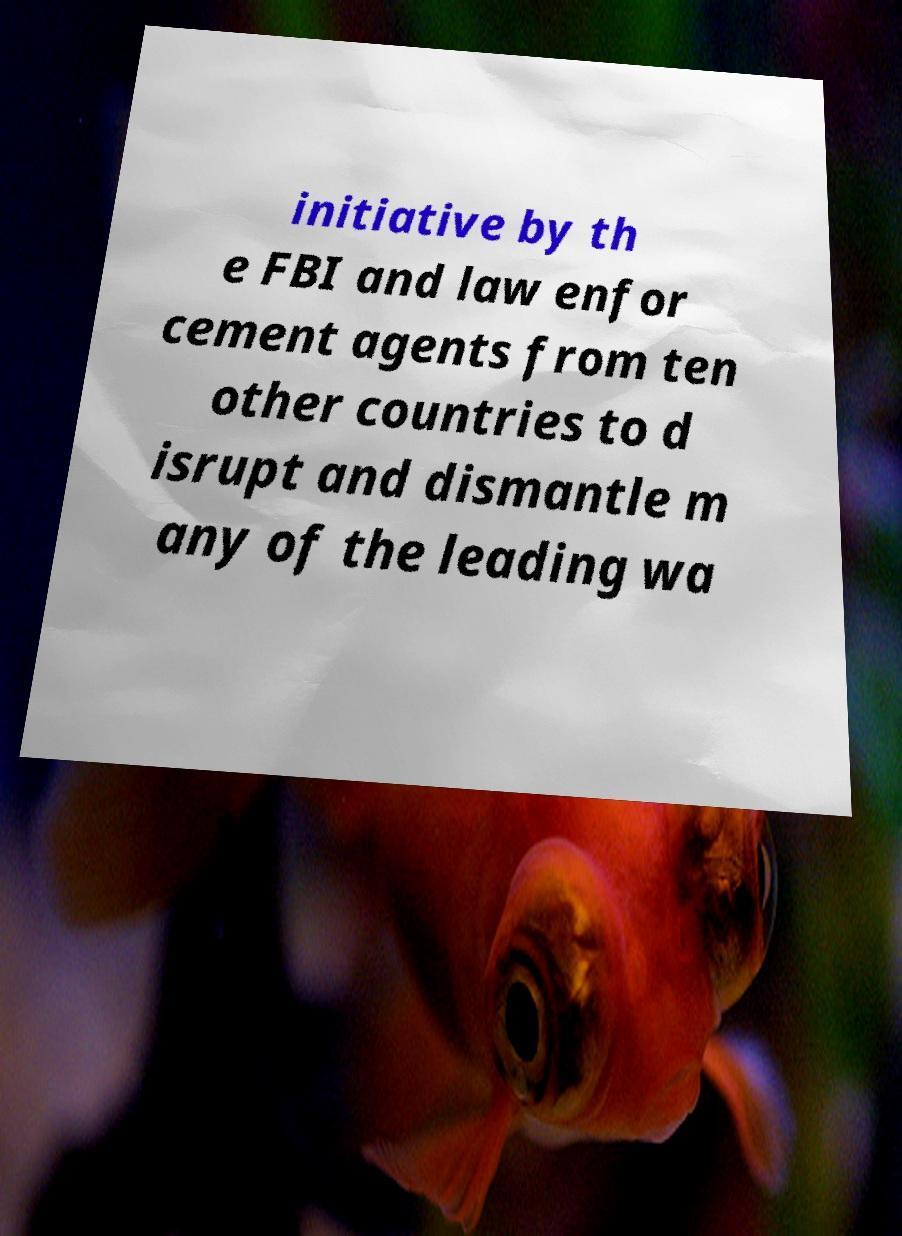Can you read and provide the text displayed in the image?This photo seems to have some interesting text. Can you extract and type it out for me? initiative by th e FBI and law enfor cement agents from ten other countries to d isrupt and dismantle m any of the leading wa 